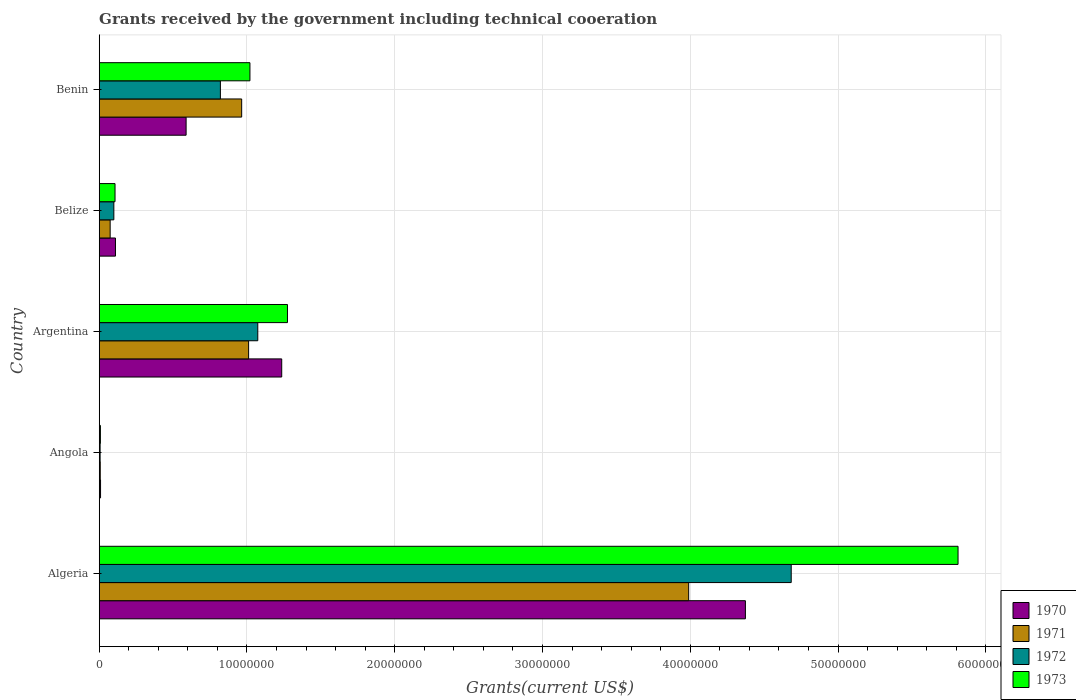How many groups of bars are there?
Ensure brevity in your answer.  5. Are the number of bars per tick equal to the number of legend labels?
Your answer should be very brief. Yes. How many bars are there on the 1st tick from the top?
Provide a succinct answer. 4. How many bars are there on the 2nd tick from the bottom?
Your answer should be compact. 4. What is the label of the 2nd group of bars from the top?
Your answer should be compact. Belize. In how many cases, is the number of bars for a given country not equal to the number of legend labels?
Offer a terse response. 0. What is the total grants received by the government in 1973 in Angola?
Ensure brevity in your answer.  8.00e+04. Across all countries, what is the maximum total grants received by the government in 1973?
Your answer should be compact. 5.81e+07. Across all countries, what is the minimum total grants received by the government in 1970?
Provide a short and direct response. 9.00e+04. In which country was the total grants received by the government in 1971 maximum?
Ensure brevity in your answer.  Algeria. In which country was the total grants received by the government in 1970 minimum?
Make the answer very short. Angola. What is the total total grants received by the government in 1972 in the graph?
Offer a terse response. 6.68e+07. What is the difference between the total grants received by the government in 1970 in Argentina and that in Belize?
Keep it short and to the point. 1.12e+07. What is the difference between the total grants received by the government in 1971 in Benin and the total grants received by the government in 1970 in Angola?
Keep it short and to the point. 9.55e+06. What is the average total grants received by the government in 1972 per country?
Provide a succinct answer. 1.34e+07. What is the difference between the total grants received by the government in 1971 and total grants received by the government in 1973 in Algeria?
Your answer should be very brief. -1.82e+07. In how many countries, is the total grants received by the government in 1971 greater than 22000000 US$?
Ensure brevity in your answer.  1. What is the ratio of the total grants received by the government in 1971 in Algeria to that in Benin?
Provide a short and direct response. 4.14. Is the difference between the total grants received by the government in 1971 in Algeria and Belize greater than the difference between the total grants received by the government in 1973 in Algeria and Belize?
Ensure brevity in your answer.  No. What is the difference between the highest and the second highest total grants received by the government in 1971?
Offer a terse response. 2.98e+07. What is the difference between the highest and the lowest total grants received by the government in 1970?
Offer a very short reply. 4.36e+07. Is the sum of the total grants received by the government in 1973 in Belize and Benin greater than the maximum total grants received by the government in 1971 across all countries?
Your response must be concise. No. How many bars are there?
Provide a short and direct response. 20. What is the difference between two consecutive major ticks on the X-axis?
Give a very brief answer. 1.00e+07. Does the graph contain any zero values?
Your response must be concise. No. Does the graph contain grids?
Give a very brief answer. Yes. How many legend labels are there?
Your answer should be compact. 4. How are the legend labels stacked?
Your answer should be compact. Vertical. What is the title of the graph?
Ensure brevity in your answer.  Grants received by the government including technical cooeration. What is the label or title of the X-axis?
Offer a terse response. Grants(current US$). What is the label or title of the Y-axis?
Give a very brief answer. Country. What is the Grants(current US$) in 1970 in Algeria?
Provide a succinct answer. 4.37e+07. What is the Grants(current US$) in 1971 in Algeria?
Your answer should be very brief. 3.99e+07. What is the Grants(current US$) in 1972 in Algeria?
Offer a terse response. 4.68e+07. What is the Grants(current US$) of 1973 in Algeria?
Provide a short and direct response. 5.81e+07. What is the Grants(current US$) in 1970 in Angola?
Give a very brief answer. 9.00e+04. What is the Grants(current US$) of 1973 in Angola?
Ensure brevity in your answer.  8.00e+04. What is the Grants(current US$) of 1970 in Argentina?
Offer a very short reply. 1.24e+07. What is the Grants(current US$) in 1971 in Argentina?
Your answer should be very brief. 1.01e+07. What is the Grants(current US$) in 1972 in Argentina?
Your answer should be very brief. 1.07e+07. What is the Grants(current US$) of 1973 in Argentina?
Provide a succinct answer. 1.27e+07. What is the Grants(current US$) of 1970 in Belize?
Provide a succinct answer. 1.10e+06. What is the Grants(current US$) of 1971 in Belize?
Keep it short and to the point. 7.40e+05. What is the Grants(current US$) of 1972 in Belize?
Give a very brief answer. 9.90e+05. What is the Grants(current US$) of 1973 in Belize?
Ensure brevity in your answer.  1.07e+06. What is the Grants(current US$) in 1970 in Benin?
Provide a succinct answer. 5.88e+06. What is the Grants(current US$) in 1971 in Benin?
Your response must be concise. 9.64e+06. What is the Grants(current US$) of 1972 in Benin?
Offer a very short reply. 8.20e+06. What is the Grants(current US$) of 1973 in Benin?
Give a very brief answer. 1.02e+07. Across all countries, what is the maximum Grants(current US$) in 1970?
Keep it short and to the point. 4.37e+07. Across all countries, what is the maximum Grants(current US$) of 1971?
Your answer should be compact. 3.99e+07. Across all countries, what is the maximum Grants(current US$) of 1972?
Ensure brevity in your answer.  4.68e+07. Across all countries, what is the maximum Grants(current US$) in 1973?
Provide a succinct answer. 5.81e+07. What is the total Grants(current US$) of 1970 in the graph?
Provide a succinct answer. 6.32e+07. What is the total Grants(current US$) in 1971 in the graph?
Your response must be concise. 6.04e+07. What is the total Grants(current US$) in 1972 in the graph?
Your answer should be very brief. 6.68e+07. What is the total Grants(current US$) in 1973 in the graph?
Your answer should be very brief. 8.22e+07. What is the difference between the Grants(current US$) of 1970 in Algeria and that in Angola?
Your response must be concise. 4.36e+07. What is the difference between the Grants(current US$) in 1971 in Algeria and that in Angola?
Keep it short and to the point. 3.98e+07. What is the difference between the Grants(current US$) of 1972 in Algeria and that in Angola?
Give a very brief answer. 4.68e+07. What is the difference between the Grants(current US$) of 1973 in Algeria and that in Angola?
Provide a succinct answer. 5.80e+07. What is the difference between the Grants(current US$) in 1970 in Algeria and that in Argentina?
Provide a succinct answer. 3.14e+07. What is the difference between the Grants(current US$) in 1971 in Algeria and that in Argentina?
Offer a terse response. 2.98e+07. What is the difference between the Grants(current US$) in 1972 in Algeria and that in Argentina?
Your answer should be compact. 3.61e+07. What is the difference between the Grants(current US$) of 1973 in Algeria and that in Argentina?
Offer a terse response. 4.54e+07. What is the difference between the Grants(current US$) of 1970 in Algeria and that in Belize?
Your answer should be very brief. 4.26e+07. What is the difference between the Grants(current US$) of 1971 in Algeria and that in Belize?
Offer a terse response. 3.92e+07. What is the difference between the Grants(current US$) in 1972 in Algeria and that in Belize?
Offer a terse response. 4.58e+07. What is the difference between the Grants(current US$) in 1973 in Algeria and that in Belize?
Provide a short and direct response. 5.70e+07. What is the difference between the Grants(current US$) of 1970 in Algeria and that in Benin?
Ensure brevity in your answer.  3.78e+07. What is the difference between the Grants(current US$) in 1971 in Algeria and that in Benin?
Provide a succinct answer. 3.02e+07. What is the difference between the Grants(current US$) in 1972 in Algeria and that in Benin?
Offer a terse response. 3.86e+07. What is the difference between the Grants(current US$) in 1973 in Algeria and that in Benin?
Your answer should be very brief. 4.79e+07. What is the difference between the Grants(current US$) in 1970 in Angola and that in Argentina?
Ensure brevity in your answer.  -1.23e+07. What is the difference between the Grants(current US$) in 1971 in Angola and that in Argentina?
Keep it short and to the point. -1.00e+07. What is the difference between the Grants(current US$) of 1972 in Angola and that in Argentina?
Ensure brevity in your answer.  -1.07e+07. What is the difference between the Grants(current US$) of 1973 in Angola and that in Argentina?
Keep it short and to the point. -1.27e+07. What is the difference between the Grants(current US$) of 1970 in Angola and that in Belize?
Make the answer very short. -1.01e+06. What is the difference between the Grants(current US$) of 1971 in Angola and that in Belize?
Provide a succinct answer. -6.70e+05. What is the difference between the Grants(current US$) of 1972 in Angola and that in Belize?
Your answer should be compact. -9.30e+05. What is the difference between the Grants(current US$) in 1973 in Angola and that in Belize?
Give a very brief answer. -9.90e+05. What is the difference between the Grants(current US$) in 1970 in Angola and that in Benin?
Ensure brevity in your answer.  -5.79e+06. What is the difference between the Grants(current US$) of 1971 in Angola and that in Benin?
Offer a terse response. -9.57e+06. What is the difference between the Grants(current US$) in 1972 in Angola and that in Benin?
Ensure brevity in your answer.  -8.14e+06. What is the difference between the Grants(current US$) of 1973 in Angola and that in Benin?
Keep it short and to the point. -1.01e+07. What is the difference between the Grants(current US$) in 1970 in Argentina and that in Belize?
Provide a succinct answer. 1.12e+07. What is the difference between the Grants(current US$) in 1971 in Argentina and that in Belize?
Your answer should be very brief. 9.37e+06. What is the difference between the Grants(current US$) in 1972 in Argentina and that in Belize?
Give a very brief answer. 9.74e+06. What is the difference between the Grants(current US$) in 1973 in Argentina and that in Belize?
Provide a succinct answer. 1.17e+07. What is the difference between the Grants(current US$) in 1970 in Argentina and that in Benin?
Offer a terse response. 6.47e+06. What is the difference between the Grants(current US$) in 1972 in Argentina and that in Benin?
Provide a succinct answer. 2.53e+06. What is the difference between the Grants(current US$) in 1973 in Argentina and that in Benin?
Give a very brief answer. 2.54e+06. What is the difference between the Grants(current US$) in 1970 in Belize and that in Benin?
Offer a very short reply. -4.78e+06. What is the difference between the Grants(current US$) of 1971 in Belize and that in Benin?
Keep it short and to the point. -8.90e+06. What is the difference between the Grants(current US$) in 1972 in Belize and that in Benin?
Keep it short and to the point. -7.21e+06. What is the difference between the Grants(current US$) of 1973 in Belize and that in Benin?
Offer a very short reply. -9.13e+06. What is the difference between the Grants(current US$) of 1970 in Algeria and the Grants(current US$) of 1971 in Angola?
Provide a succinct answer. 4.37e+07. What is the difference between the Grants(current US$) of 1970 in Algeria and the Grants(current US$) of 1972 in Angola?
Your answer should be compact. 4.37e+07. What is the difference between the Grants(current US$) in 1970 in Algeria and the Grants(current US$) in 1973 in Angola?
Provide a succinct answer. 4.36e+07. What is the difference between the Grants(current US$) of 1971 in Algeria and the Grants(current US$) of 1972 in Angola?
Provide a short and direct response. 3.98e+07. What is the difference between the Grants(current US$) of 1971 in Algeria and the Grants(current US$) of 1973 in Angola?
Provide a succinct answer. 3.98e+07. What is the difference between the Grants(current US$) of 1972 in Algeria and the Grants(current US$) of 1973 in Angola?
Make the answer very short. 4.68e+07. What is the difference between the Grants(current US$) of 1970 in Algeria and the Grants(current US$) of 1971 in Argentina?
Ensure brevity in your answer.  3.36e+07. What is the difference between the Grants(current US$) in 1970 in Algeria and the Grants(current US$) in 1972 in Argentina?
Give a very brief answer. 3.30e+07. What is the difference between the Grants(current US$) of 1970 in Algeria and the Grants(current US$) of 1973 in Argentina?
Provide a short and direct response. 3.10e+07. What is the difference between the Grants(current US$) in 1971 in Algeria and the Grants(current US$) in 1972 in Argentina?
Make the answer very short. 2.92e+07. What is the difference between the Grants(current US$) in 1971 in Algeria and the Grants(current US$) in 1973 in Argentina?
Offer a terse response. 2.72e+07. What is the difference between the Grants(current US$) in 1972 in Algeria and the Grants(current US$) in 1973 in Argentina?
Provide a succinct answer. 3.41e+07. What is the difference between the Grants(current US$) of 1970 in Algeria and the Grants(current US$) of 1971 in Belize?
Your response must be concise. 4.30e+07. What is the difference between the Grants(current US$) of 1970 in Algeria and the Grants(current US$) of 1972 in Belize?
Make the answer very short. 4.27e+07. What is the difference between the Grants(current US$) in 1970 in Algeria and the Grants(current US$) in 1973 in Belize?
Provide a short and direct response. 4.27e+07. What is the difference between the Grants(current US$) of 1971 in Algeria and the Grants(current US$) of 1972 in Belize?
Your answer should be very brief. 3.89e+07. What is the difference between the Grants(current US$) in 1971 in Algeria and the Grants(current US$) in 1973 in Belize?
Provide a succinct answer. 3.88e+07. What is the difference between the Grants(current US$) in 1972 in Algeria and the Grants(current US$) in 1973 in Belize?
Ensure brevity in your answer.  4.58e+07. What is the difference between the Grants(current US$) in 1970 in Algeria and the Grants(current US$) in 1971 in Benin?
Your answer should be very brief. 3.41e+07. What is the difference between the Grants(current US$) of 1970 in Algeria and the Grants(current US$) of 1972 in Benin?
Give a very brief answer. 3.55e+07. What is the difference between the Grants(current US$) of 1970 in Algeria and the Grants(current US$) of 1973 in Benin?
Provide a short and direct response. 3.35e+07. What is the difference between the Grants(current US$) in 1971 in Algeria and the Grants(current US$) in 1972 in Benin?
Make the answer very short. 3.17e+07. What is the difference between the Grants(current US$) in 1971 in Algeria and the Grants(current US$) in 1973 in Benin?
Offer a very short reply. 2.97e+07. What is the difference between the Grants(current US$) of 1972 in Algeria and the Grants(current US$) of 1973 in Benin?
Ensure brevity in your answer.  3.66e+07. What is the difference between the Grants(current US$) in 1970 in Angola and the Grants(current US$) in 1971 in Argentina?
Give a very brief answer. -1.00e+07. What is the difference between the Grants(current US$) in 1970 in Angola and the Grants(current US$) in 1972 in Argentina?
Provide a succinct answer. -1.06e+07. What is the difference between the Grants(current US$) of 1970 in Angola and the Grants(current US$) of 1973 in Argentina?
Your answer should be very brief. -1.26e+07. What is the difference between the Grants(current US$) of 1971 in Angola and the Grants(current US$) of 1972 in Argentina?
Offer a terse response. -1.07e+07. What is the difference between the Grants(current US$) in 1971 in Angola and the Grants(current US$) in 1973 in Argentina?
Your answer should be very brief. -1.27e+07. What is the difference between the Grants(current US$) in 1972 in Angola and the Grants(current US$) in 1973 in Argentina?
Offer a terse response. -1.27e+07. What is the difference between the Grants(current US$) in 1970 in Angola and the Grants(current US$) in 1971 in Belize?
Your response must be concise. -6.50e+05. What is the difference between the Grants(current US$) in 1970 in Angola and the Grants(current US$) in 1972 in Belize?
Offer a terse response. -9.00e+05. What is the difference between the Grants(current US$) in 1970 in Angola and the Grants(current US$) in 1973 in Belize?
Your response must be concise. -9.80e+05. What is the difference between the Grants(current US$) of 1971 in Angola and the Grants(current US$) of 1972 in Belize?
Your answer should be compact. -9.20e+05. What is the difference between the Grants(current US$) of 1971 in Angola and the Grants(current US$) of 1973 in Belize?
Your answer should be very brief. -1.00e+06. What is the difference between the Grants(current US$) of 1972 in Angola and the Grants(current US$) of 1973 in Belize?
Provide a short and direct response. -1.01e+06. What is the difference between the Grants(current US$) of 1970 in Angola and the Grants(current US$) of 1971 in Benin?
Give a very brief answer. -9.55e+06. What is the difference between the Grants(current US$) in 1970 in Angola and the Grants(current US$) in 1972 in Benin?
Offer a very short reply. -8.11e+06. What is the difference between the Grants(current US$) in 1970 in Angola and the Grants(current US$) in 1973 in Benin?
Ensure brevity in your answer.  -1.01e+07. What is the difference between the Grants(current US$) of 1971 in Angola and the Grants(current US$) of 1972 in Benin?
Give a very brief answer. -8.13e+06. What is the difference between the Grants(current US$) in 1971 in Angola and the Grants(current US$) in 1973 in Benin?
Make the answer very short. -1.01e+07. What is the difference between the Grants(current US$) in 1972 in Angola and the Grants(current US$) in 1973 in Benin?
Ensure brevity in your answer.  -1.01e+07. What is the difference between the Grants(current US$) of 1970 in Argentina and the Grants(current US$) of 1971 in Belize?
Give a very brief answer. 1.16e+07. What is the difference between the Grants(current US$) in 1970 in Argentina and the Grants(current US$) in 1972 in Belize?
Keep it short and to the point. 1.14e+07. What is the difference between the Grants(current US$) of 1970 in Argentina and the Grants(current US$) of 1973 in Belize?
Your response must be concise. 1.13e+07. What is the difference between the Grants(current US$) of 1971 in Argentina and the Grants(current US$) of 1972 in Belize?
Your answer should be compact. 9.12e+06. What is the difference between the Grants(current US$) of 1971 in Argentina and the Grants(current US$) of 1973 in Belize?
Give a very brief answer. 9.04e+06. What is the difference between the Grants(current US$) of 1972 in Argentina and the Grants(current US$) of 1973 in Belize?
Make the answer very short. 9.66e+06. What is the difference between the Grants(current US$) of 1970 in Argentina and the Grants(current US$) of 1971 in Benin?
Your answer should be compact. 2.71e+06. What is the difference between the Grants(current US$) of 1970 in Argentina and the Grants(current US$) of 1972 in Benin?
Provide a short and direct response. 4.15e+06. What is the difference between the Grants(current US$) of 1970 in Argentina and the Grants(current US$) of 1973 in Benin?
Make the answer very short. 2.15e+06. What is the difference between the Grants(current US$) in 1971 in Argentina and the Grants(current US$) in 1972 in Benin?
Your answer should be very brief. 1.91e+06. What is the difference between the Grants(current US$) in 1971 in Argentina and the Grants(current US$) in 1973 in Benin?
Your answer should be compact. -9.00e+04. What is the difference between the Grants(current US$) of 1972 in Argentina and the Grants(current US$) of 1973 in Benin?
Offer a terse response. 5.30e+05. What is the difference between the Grants(current US$) of 1970 in Belize and the Grants(current US$) of 1971 in Benin?
Your answer should be compact. -8.54e+06. What is the difference between the Grants(current US$) of 1970 in Belize and the Grants(current US$) of 1972 in Benin?
Give a very brief answer. -7.10e+06. What is the difference between the Grants(current US$) in 1970 in Belize and the Grants(current US$) in 1973 in Benin?
Provide a succinct answer. -9.10e+06. What is the difference between the Grants(current US$) in 1971 in Belize and the Grants(current US$) in 1972 in Benin?
Offer a terse response. -7.46e+06. What is the difference between the Grants(current US$) in 1971 in Belize and the Grants(current US$) in 1973 in Benin?
Provide a succinct answer. -9.46e+06. What is the difference between the Grants(current US$) in 1972 in Belize and the Grants(current US$) in 1973 in Benin?
Ensure brevity in your answer.  -9.21e+06. What is the average Grants(current US$) of 1970 per country?
Ensure brevity in your answer.  1.26e+07. What is the average Grants(current US$) of 1971 per country?
Your answer should be compact. 1.21e+07. What is the average Grants(current US$) in 1972 per country?
Your answer should be very brief. 1.34e+07. What is the average Grants(current US$) in 1973 per country?
Make the answer very short. 1.64e+07. What is the difference between the Grants(current US$) in 1970 and Grants(current US$) in 1971 in Algeria?
Keep it short and to the point. 3.84e+06. What is the difference between the Grants(current US$) in 1970 and Grants(current US$) in 1972 in Algeria?
Your answer should be very brief. -3.10e+06. What is the difference between the Grants(current US$) of 1970 and Grants(current US$) of 1973 in Algeria?
Ensure brevity in your answer.  -1.44e+07. What is the difference between the Grants(current US$) of 1971 and Grants(current US$) of 1972 in Algeria?
Offer a very short reply. -6.94e+06. What is the difference between the Grants(current US$) of 1971 and Grants(current US$) of 1973 in Algeria?
Give a very brief answer. -1.82e+07. What is the difference between the Grants(current US$) in 1972 and Grants(current US$) in 1973 in Algeria?
Ensure brevity in your answer.  -1.13e+07. What is the difference between the Grants(current US$) of 1970 and Grants(current US$) of 1971 in Angola?
Your answer should be very brief. 2.00e+04. What is the difference between the Grants(current US$) of 1970 and Grants(current US$) of 1973 in Angola?
Offer a terse response. 10000. What is the difference between the Grants(current US$) of 1971 and Grants(current US$) of 1972 in Angola?
Ensure brevity in your answer.  10000. What is the difference between the Grants(current US$) in 1970 and Grants(current US$) in 1971 in Argentina?
Keep it short and to the point. 2.24e+06. What is the difference between the Grants(current US$) in 1970 and Grants(current US$) in 1972 in Argentina?
Ensure brevity in your answer.  1.62e+06. What is the difference between the Grants(current US$) of 1970 and Grants(current US$) of 1973 in Argentina?
Give a very brief answer. -3.90e+05. What is the difference between the Grants(current US$) in 1971 and Grants(current US$) in 1972 in Argentina?
Make the answer very short. -6.20e+05. What is the difference between the Grants(current US$) in 1971 and Grants(current US$) in 1973 in Argentina?
Keep it short and to the point. -2.63e+06. What is the difference between the Grants(current US$) of 1972 and Grants(current US$) of 1973 in Argentina?
Provide a short and direct response. -2.01e+06. What is the difference between the Grants(current US$) of 1970 and Grants(current US$) of 1973 in Belize?
Your response must be concise. 3.00e+04. What is the difference between the Grants(current US$) of 1971 and Grants(current US$) of 1973 in Belize?
Offer a terse response. -3.30e+05. What is the difference between the Grants(current US$) in 1970 and Grants(current US$) in 1971 in Benin?
Offer a very short reply. -3.76e+06. What is the difference between the Grants(current US$) in 1970 and Grants(current US$) in 1972 in Benin?
Give a very brief answer. -2.32e+06. What is the difference between the Grants(current US$) of 1970 and Grants(current US$) of 1973 in Benin?
Offer a terse response. -4.32e+06. What is the difference between the Grants(current US$) of 1971 and Grants(current US$) of 1972 in Benin?
Offer a very short reply. 1.44e+06. What is the difference between the Grants(current US$) in 1971 and Grants(current US$) in 1973 in Benin?
Your answer should be compact. -5.60e+05. What is the ratio of the Grants(current US$) of 1970 in Algeria to that in Angola?
Your answer should be very brief. 485.89. What is the ratio of the Grants(current US$) in 1971 in Algeria to that in Angola?
Offer a terse response. 569.86. What is the ratio of the Grants(current US$) in 1972 in Algeria to that in Angola?
Provide a succinct answer. 780.5. What is the ratio of the Grants(current US$) of 1973 in Algeria to that in Angola?
Ensure brevity in your answer.  726.5. What is the ratio of the Grants(current US$) of 1970 in Algeria to that in Argentina?
Provide a short and direct response. 3.54. What is the ratio of the Grants(current US$) in 1971 in Algeria to that in Argentina?
Your answer should be very brief. 3.95. What is the ratio of the Grants(current US$) in 1972 in Algeria to that in Argentina?
Give a very brief answer. 4.36. What is the ratio of the Grants(current US$) in 1973 in Algeria to that in Argentina?
Offer a very short reply. 4.56. What is the ratio of the Grants(current US$) in 1970 in Algeria to that in Belize?
Your response must be concise. 39.75. What is the ratio of the Grants(current US$) of 1971 in Algeria to that in Belize?
Your answer should be compact. 53.91. What is the ratio of the Grants(current US$) in 1972 in Algeria to that in Belize?
Keep it short and to the point. 47.3. What is the ratio of the Grants(current US$) in 1973 in Algeria to that in Belize?
Offer a terse response. 54.32. What is the ratio of the Grants(current US$) of 1970 in Algeria to that in Benin?
Your answer should be compact. 7.44. What is the ratio of the Grants(current US$) in 1971 in Algeria to that in Benin?
Offer a terse response. 4.14. What is the ratio of the Grants(current US$) of 1972 in Algeria to that in Benin?
Make the answer very short. 5.71. What is the ratio of the Grants(current US$) in 1973 in Algeria to that in Benin?
Provide a succinct answer. 5.7. What is the ratio of the Grants(current US$) in 1970 in Angola to that in Argentina?
Ensure brevity in your answer.  0.01. What is the ratio of the Grants(current US$) of 1971 in Angola to that in Argentina?
Ensure brevity in your answer.  0.01. What is the ratio of the Grants(current US$) of 1972 in Angola to that in Argentina?
Ensure brevity in your answer.  0.01. What is the ratio of the Grants(current US$) of 1973 in Angola to that in Argentina?
Offer a very short reply. 0.01. What is the ratio of the Grants(current US$) of 1970 in Angola to that in Belize?
Keep it short and to the point. 0.08. What is the ratio of the Grants(current US$) of 1971 in Angola to that in Belize?
Ensure brevity in your answer.  0.09. What is the ratio of the Grants(current US$) in 1972 in Angola to that in Belize?
Ensure brevity in your answer.  0.06. What is the ratio of the Grants(current US$) in 1973 in Angola to that in Belize?
Offer a very short reply. 0.07. What is the ratio of the Grants(current US$) of 1970 in Angola to that in Benin?
Ensure brevity in your answer.  0.02. What is the ratio of the Grants(current US$) of 1971 in Angola to that in Benin?
Ensure brevity in your answer.  0.01. What is the ratio of the Grants(current US$) in 1972 in Angola to that in Benin?
Provide a succinct answer. 0.01. What is the ratio of the Grants(current US$) of 1973 in Angola to that in Benin?
Give a very brief answer. 0.01. What is the ratio of the Grants(current US$) in 1970 in Argentina to that in Belize?
Make the answer very short. 11.23. What is the ratio of the Grants(current US$) in 1971 in Argentina to that in Belize?
Your response must be concise. 13.66. What is the ratio of the Grants(current US$) of 1972 in Argentina to that in Belize?
Ensure brevity in your answer.  10.84. What is the ratio of the Grants(current US$) of 1973 in Argentina to that in Belize?
Your answer should be very brief. 11.91. What is the ratio of the Grants(current US$) in 1970 in Argentina to that in Benin?
Make the answer very short. 2.1. What is the ratio of the Grants(current US$) of 1971 in Argentina to that in Benin?
Ensure brevity in your answer.  1.05. What is the ratio of the Grants(current US$) of 1972 in Argentina to that in Benin?
Provide a short and direct response. 1.31. What is the ratio of the Grants(current US$) of 1973 in Argentina to that in Benin?
Ensure brevity in your answer.  1.25. What is the ratio of the Grants(current US$) of 1970 in Belize to that in Benin?
Keep it short and to the point. 0.19. What is the ratio of the Grants(current US$) of 1971 in Belize to that in Benin?
Provide a succinct answer. 0.08. What is the ratio of the Grants(current US$) of 1972 in Belize to that in Benin?
Your answer should be very brief. 0.12. What is the ratio of the Grants(current US$) in 1973 in Belize to that in Benin?
Provide a short and direct response. 0.1. What is the difference between the highest and the second highest Grants(current US$) in 1970?
Offer a terse response. 3.14e+07. What is the difference between the highest and the second highest Grants(current US$) in 1971?
Ensure brevity in your answer.  2.98e+07. What is the difference between the highest and the second highest Grants(current US$) of 1972?
Provide a short and direct response. 3.61e+07. What is the difference between the highest and the second highest Grants(current US$) of 1973?
Keep it short and to the point. 4.54e+07. What is the difference between the highest and the lowest Grants(current US$) of 1970?
Provide a short and direct response. 4.36e+07. What is the difference between the highest and the lowest Grants(current US$) in 1971?
Give a very brief answer. 3.98e+07. What is the difference between the highest and the lowest Grants(current US$) of 1972?
Give a very brief answer. 4.68e+07. What is the difference between the highest and the lowest Grants(current US$) in 1973?
Ensure brevity in your answer.  5.80e+07. 